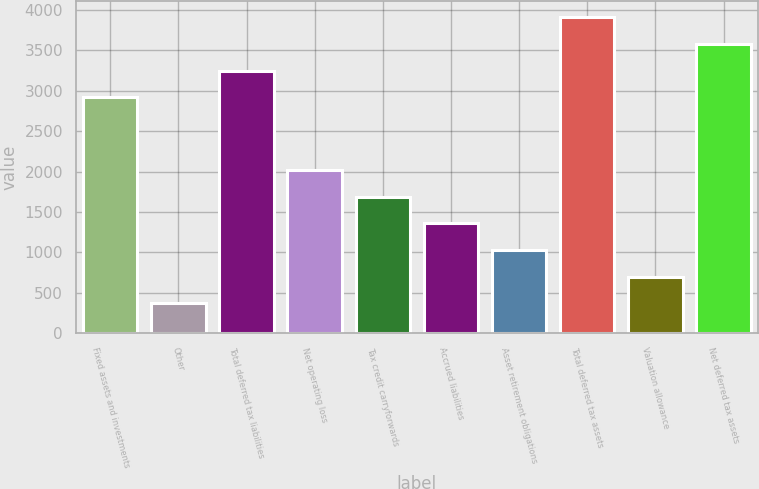<chart> <loc_0><loc_0><loc_500><loc_500><bar_chart><fcel>Fixed assets and investments<fcel>Other<fcel>Total deferred tax liabilities<fcel>Net operating loss<fcel>Tax credit carryforwards<fcel>Accrued liabilities<fcel>Asset retirement obligations<fcel>Total deferred tax assets<fcel>Valuation allowance<fcel>Net deferred tax assets<nl><fcel>2918<fcel>369.8<fcel>3247.8<fcel>2018.8<fcel>1689<fcel>1359.2<fcel>1029.4<fcel>3907.4<fcel>699.6<fcel>3577.6<nl></chart> 